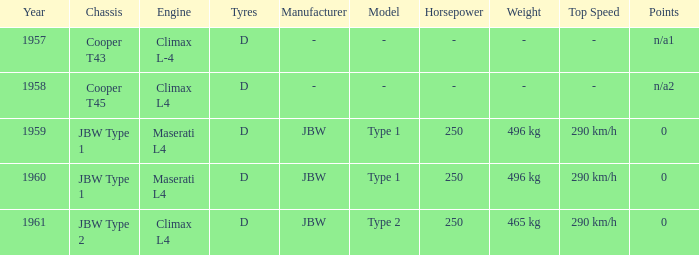What company built the chassis for a year later than 1959 and a climax l4 engine? JBW Type 2. 